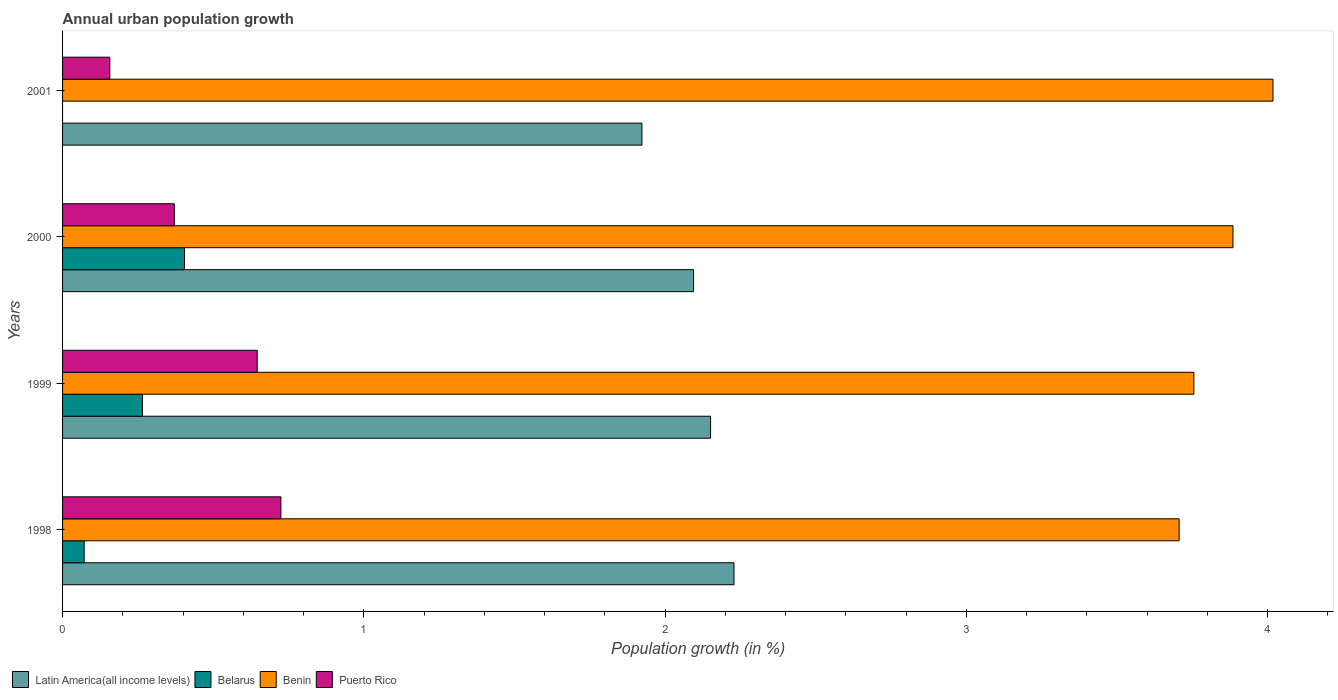How many different coloured bars are there?
Ensure brevity in your answer.  4. How many bars are there on the 4th tick from the bottom?
Offer a very short reply. 3. Across all years, what is the maximum percentage of urban population growth in Puerto Rico?
Provide a short and direct response. 0.72. Across all years, what is the minimum percentage of urban population growth in Puerto Rico?
Your answer should be compact. 0.16. What is the total percentage of urban population growth in Belarus in the graph?
Offer a terse response. 0.74. What is the difference between the percentage of urban population growth in Puerto Rico in 1998 and that in 2000?
Your answer should be compact. 0.35. What is the difference between the percentage of urban population growth in Belarus in 2000 and the percentage of urban population growth in Latin America(all income levels) in 1998?
Give a very brief answer. -1.82. What is the average percentage of urban population growth in Puerto Rico per year?
Provide a succinct answer. 0.47. In the year 2001, what is the difference between the percentage of urban population growth in Puerto Rico and percentage of urban population growth in Benin?
Offer a very short reply. -3.86. What is the ratio of the percentage of urban population growth in Belarus in 1999 to that in 2000?
Give a very brief answer. 0.66. Is the difference between the percentage of urban population growth in Puerto Rico in 1999 and 2000 greater than the difference between the percentage of urban population growth in Benin in 1999 and 2000?
Give a very brief answer. Yes. What is the difference between the highest and the second highest percentage of urban population growth in Puerto Rico?
Give a very brief answer. 0.08. What is the difference between the highest and the lowest percentage of urban population growth in Latin America(all income levels)?
Provide a short and direct response. 0.31. Is the sum of the percentage of urban population growth in Belarus in 1999 and 2000 greater than the maximum percentage of urban population growth in Latin America(all income levels) across all years?
Make the answer very short. No. Is it the case that in every year, the sum of the percentage of urban population growth in Benin and percentage of urban population growth in Puerto Rico is greater than the sum of percentage of urban population growth in Belarus and percentage of urban population growth in Latin America(all income levels)?
Your response must be concise. No. Are all the bars in the graph horizontal?
Offer a terse response. Yes. Are the values on the major ticks of X-axis written in scientific E-notation?
Provide a succinct answer. No. Where does the legend appear in the graph?
Provide a short and direct response. Bottom left. How are the legend labels stacked?
Provide a short and direct response. Horizontal. What is the title of the graph?
Provide a succinct answer. Annual urban population growth. What is the label or title of the X-axis?
Your response must be concise. Population growth (in %). What is the Population growth (in %) of Latin America(all income levels) in 1998?
Your answer should be very brief. 2.23. What is the Population growth (in %) of Belarus in 1998?
Give a very brief answer. 0.07. What is the Population growth (in %) of Benin in 1998?
Your answer should be very brief. 3.71. What is the Population growth (in %) in Puerto Rico in 1998?
Your response must be concise. 0.72. What is the Population growth (in %) of Latin America(all income levels) in 1999?
Ensure brevity in your answer.  2.15. What is the Population growth (in %) of Belarus in 1999?
Provide a short and direct response. 0.27. What is the Population growth (in %) in Benin in 1999?
Keep it short and to the point. 3.76. What is the Population growth (in %) of Puerto Rico in 1999?
Provide a succinct answer. 0.65. What is the Population growth (in %) of Latin America(all income levels) in 2000?
Give a very brief answer. 2.09. What is the Population growth (in %) of Belarus in 2000?
Keep it short and to the point. 0.4. What is the Population growth (in %) in Benin in 2000?
Ensure brevity in your answer.  3.88. What is the Population growth (in %) in Puerto Rico in 2000?
Make the answer very short. 0.37. What is the Population growth (in %) in Latin America(all income levels) in 2001?
Your answer should be compact. 1.92. What is the Population growth (in %) of Benin in 2001?
Your response must be concise. 4.02. What is the Population growth (in %) in Puerto Rico in 2001?
Provide a succinct answer. 0.16. Across all years, what is the maximum Population growth (in %) of Latin America(all income levels)?
Keep it short and to the point. 2.23. Across all years, what is the maximum Population growth (in %) in Belarus?
Your response must be concise. 0.4. Across all years, what is the maximum Population growth (in %) in Benin?
Your answer should be compact. 4.02. Across all years, what is the maximum Population growth (in %) in Puerto Rico?
Your answer should be very brief. 0.72. Across all years, what is the minimum Population growth (in %) in Latin America(all income levels)?
Your answer should be compact. 1.92. Across all years, what is the minimum Population growth (in %) in Belarus?
Offer a very short reply. 0. Across all years, what is the minimum Population growth (in %) in Benin?
Your response must be concise. 3.71. Across all years, what is the minimum Population growth (in %) in Puerto Rico?
Provide a short and direct response. 0.16. What is the total Population growth (in %) of Latin America(all income levels) in the graph?
Make the answer very short. 8.4. What is the total Population growth (in %) of Belarus in the graph?
Provide a succinct answer. 0.74. What is the total Population growth (in %) in Benin in the graph?
Your answer should be compact. 15.36. What is the total Population growth (in %) of Puerto Rico in the graph?
Offer a very short reply. 1.9. What is the difference between the Population growth (in %) in Latin America(all income levels) in 1998 and that in 1999?
Give a very brief answer. 0.08. What is the difference between the Population growth (in %) of Belarus in 1998 and that in 1999?
Keep it short and to the point. -0.19. What is the difference between the Population growth (in %) in Benin in 1998 and that in 1999?
Offer a terse response. -0.05. What is the difference between the Population growth (in %) of Puerto Rico in 1998 and that in 1999?
Give a very brief answer. 0.08. What is the difference between the Population growth (in %) of Latin America(all income levels) in 1998 and that in 2000?
Ensure brevity in your answer.  0.13. What is the difference between the Population growth (in %) in Belarus in 1998 and that in 2000?
Provide a short and direct response. -0.33. What is the difference between the Population growth (in %) of Benin in 1998 and that in 2000?
Give a very brief answer. -0.18. What is the difference between the Population growth (in %) in Puerto Rico in 1998 and that in 2000?
Your answer should be compact. 0.35. What is the difference between the Population growth (in %) of Latin America(all income levels) in 1998 and that in 2001?
Keep it short and to the point. 0.31. What is the difference between the Population growth (in %) of Benin in 1998 and that in 2001?
Your answer should be very brief. -0.31. What is the difference between the Population growth (in %) in Puerto Rico in 1998 and that in 2001?
Ensure brevity in your answer.  0.57. What is the difference between the Population growth (in %) in Latin America(all income levels) in 1999 and that in 2000?
Ensure brevity in your answer.  0.06. What is the difference between the Population growth (in %) in Belarus in 1999 and that in 2000?
Offer a very short reply. -0.14. What is the difference between the Population growth (in %) of Benin in 1999 and that in 2000?
Offer a very short reply. -0.13. What is the difference between the Population growth (in %) in Puerto Rico in 1999 and that in 2000?
Your answer should be very brief. 0.28. What is the difference between the Population growth (in %) in Latin America(all income levels) in 1999 and that in 2001?
Offer a very short reply. 0.23. What is the difference between the Population growth (in %) of Benin in 1999 and that in 2001?
Provide a succinct answer. -0.26. What is the difference between the Population growth (in %) in Puerto Rico in 1999 and that in 2001?
Offer a terse response. 0.49. What is the difference between the Population growth (in %) of Latin America(all income levels) in 2000 and that in 2001?
Your response must be concise. 0.17. What is the difference between the Population growth (in %) in Benin in 2000 and that in 2001?
Your answer should be very brief. -0.13. What is the difference between the Population growth (in %) in Puerto Rico in 2000 and that in 2001?
Your response must be concise. 0.21. What is the difference between the Population growth (in %) in Latin America(all income levels) in 1998 and the Population growth (in %) in Belarus in 1999?
Make the answer very short. 1.96. What is the difference between the Population growth (in %) in Latin America(all income levels) in 1998 and the Population growth (in %) in Benin in 1999?
Offer a very short reply. -1.53. What is the difference between the Population growth (in %) of Latin America(all income levels) in 1998 and the Population growth (in %) of Puerto Rico in 1999?
Offer a terse response. 1.58. What is the difference between the Population growth (in %) in Belarus in 1998 and the Population growth (in %) in Benin in 1999?
Give a very brief answer. -3.68. What is the difference between the Population growth (in %) of Belarus in 1998 and the Population growth (in %) of Puerto Rico in 1999?
Offer a terse response. -0.57. What is the difference between the Population growth (in %) of Benin in 1998 and the Population growth (in %) of Puerto Rico in 1999?
Your answer should be very brief. 3.06. What is the difference between the Population growth (in %) in Latin America(all income levels) in 1998 and the Population growth (in %) in Belarus in 2000?
Your response must be concise. 1.82. What is the difference between the Population growth (in %) in Latin America(all income levels) in 1998 and the Population growth (in %) in Benin in 2000?
Provide a succinct answer. -1.66. What is the difference between the Population growth (in %) in Latin America(all income levels) in 1998 and the Population growth (in %) in Puerto Rico in 2000?
Offer a very short reply. 1.86. What is the difference between the Population growth (in %) in Belarus in 1998 and the Population growth (in %) in Benin in 2000?
Make the answer very short. -3.81. What is the difference between the Population growth (in %) in Belarus in 1998 and the Population growth (in %) in Puerto Rico in 2000?
Your answer should be compact. -0.3. What is the difference between the Population growth (in %) in Benin in 1998 and the Population growth (in %) in Puerto Rico in 2000?
Your answer should be compact. 3.34. What is the difference between the Population growth (in %) in Latin America(all income levels) in 1998 and the Population growth (in %) in Benin in 2001?
Give a very brief answer. -1.79. What is the difference between the Population growth (in %) in Latin America(all income levels) in 1998 and the Population growth (in %) in Puerto Rico in 2001?
Your answer should be compact. 2.07. What is the difference between the Population growth (in %) in Belarus in 1998 and the Population growth (in %) in Benin in 2001?
Provide a short and direct response. -3.95. What is the difference between the Population growth (in %) of Belarus in 1998 and the Population growth (in %) of Puerto Rico in 2001?
Give a very brief answer. -0.09. What is the difference between the Population growth (in %) in Benin in 1998 and the Population growth (in %) in Puerto Rico in 2001?
Your answer should be compact. 3.55. What is the difference between the Population growth (in %) in Latin America(all income levels) in 1999 and the Population growth (in %) in Belarus in 2000?
Offer a terse response. 1.75. What is the difference between the Population growth (in %) of Latin America(all income levels) in 1999 and the Population growth (in %) of Benin in 2000?
Provide a short and direct response. -1.73. What is the difference between the Population growth (in %) of Latin America(all income levels) in 1999 and the Population growth (in %) of Puerto Rico in 2000?
Keep it short and to the point. 1.78. What is the difference between the Population growth (in %) in Belarus in 1999 and the Population growth (in %) in Benin in 2000?
Your answer should be very brief. -3.62. What is the difference between the Population growth (in %) of Belarus in 1999 and the Population growth (in %) of Puerto Rico in 2000?
Provide a succinct answer. -0.11. What is the difference between the Population growth (in %) of Benin in 1999 and the Population growth (in %) of Puerto Rico in 2000?
Ensure brevity in your answer.  3.38. What is the difference between the Population growth (in %) of Latin America(all income levels) in 1999 and the Population growth (in %) of Benin in 2001?
Offer a terse response. -1.87. What is the difference between the Population growth (in %) in Latin America(all income levels) in 1999 and the Population growth (in %) in Puerto Rico in 2001?
Ensure brevity in your answer.  1.99. What is the difference between the Population growth (in %) of Belarus in 1999 and the Population growth (in %) of Benin in 2001?
Your answer should be very brief. -3.75. What is the difference between the Population growth (in %) in Belarus in 1999 and the Population growth (in %) in Puerto Rico in 2001?
Your answer should be very brief. 0.11. What is the difference between the Population growth (in %) in Benin in 1999 and the Population growth (in %) in Puerto Rico in 2001?
Give a very brief answer. 3.6. What is the difference between the Population growth (in %) of Latin America(all income levels) in 2000 and the Population growth (in %) of Benin in 2001?
Make the answer very short. -1.92. What is the difference between the Population growth (in %) of Latin America(all income levels) in 2000 and the Population growth (in %) of Puerto Rico in 2001?
Provide a short and direct response. 1.94. What is the difference between the Population growth (in %) of Belarus in 2000 and the Population growth (in %) of Benin in 2001?
Offer a very short reply. -3.61. What is the difference between the Population growth (in %) of Belarus in 2000 and the Population growth (in %) of Puerto Rico in 2001?
Offer a very short reply. 0.25. What is the difference between the Population growth (in %) of Benin in 2000 and the Population growth (in %) of Puerto Rico in 2001?
Provide a succinct answer. 3.73. What is the average Population growth (in %) in Latin America(all income levels) per year?
Provide a succinct answer. 2.1. What is the average Population growth (in %) in Belarus per year?
Give a very brief answer. 0.19. What is the average Population growth (in %) of Benin per year?
Provide a short and direct response. 3.84. What is the average Population growth (in %) of Puerto Rico per year?
Give a very brief answer. 0.47. In the year 1998, what is the difference between the Population growth (in %) of Latin America(all income levels) and Population growth (in %) of Belarus?
Make the answer very short. 2.16. In the year 1998, what is the difference between the Population growth (in %) in Latin America(all income levels) and Population growth (in %) in Benin?
Make the answer very short. -1.48. In the year 1998, what is the difference between the Population growth (in %) in Latin America(all income levels) and Population growth (in %) in Puerto Rico?
Give a very brief answer. 1.5. In the year 1998, what is the difference between the Population growth (in %) of Belarus and Population growth (in %) of Benin?
Offer a very short reply. -3.63. In the year 1998, what is the difference between the Population growth (in %) in Belarus and Population growth (in %) in Puerto Rico?
Offer a terse response. -0.65. In the year 1998, what is the difference between the Population growth (in %) of Benin and Population growth (in %) of Puerto Rico?
Your answer should be very brief. 2.98. In the year 1999, what is the difference between the Population growth (in %) of Latin America(all income levels) and Population growth (in %) of Belarus?
Give a very brief answer. 1.89. In the year 1999, what is the difference between the Population growth (in %) of Latin America(all income levels) and Population growth (in %) of Benin?
Your response must be concise. -1.6. In the year 1999, what is the difference between the Population growth (in %) of Latin America(all income levels) and Population growth (in %) of Puerto Rico?
Offer a terse response. 1.5. In the year 1999, what is the difference between the Population growth (in %) in Belarus and Population growth (in %) in Benin?
Offer a terse response. -3.49. In the year 1999, what is the difference between the Population growth (in %) of Belarus and Population growth (in %) of Puerto Rico?
Offer a very short reply. -0.38. In the year 1999, what is the difference between the Population growth (in %) of Benin and Population growth (in %) of Puerto Rico?
Offer a terse response. 3.11. In the year 2000, what is the difference between the Population growth (in %) of Latin America(all income levels) and Population growth (in %) of Belarus?
Your answer should be very brief. 1.69. In the year 2000, what is the difference between the Population growth (in %) of Latin America(all income levels) and Population growth (in %) of Benin?
Make the answer very short. -1.79. In the year 2000, what is the difference between the Population growth (in %) of Latin America(all income levels) and Population growth (in %) of Puerto Rico?
Provide a short and direct response. 1.72. In the year 2000, what is the difference between the Population growth (in %) of Belarus and Population growth (in %) of Benin?
Provide a succinct answer. -3.48. In the year 2000, what is the difference between the Population growth (in %) in Belarus and Population growth (in %) in Puerto Rico?
Offer a terse response. 0.03. In the year 2000, what is the difference between the Population growth (in %) of Benin and Population growth (in %) of Puerto Rico?
Keep it short and to the point. 3.51. In the year 2001, what is the difference between the Population growth (in %) of Latin America(all income levels) and Population growth (in %) of Benin?
Your answer should be very brief. -2.09. In the year 2001, what is the difference between the Population growth (in %) of Latin America(all income levels) and Population growth (in %) of Puerto Rico?
Give a very brief answer. 1.77. In the year 2001, what is the difference between the Population growth (in %) in Benin and Population growth (in %) in Puerto Rico?
Offer a very short reply. 3.86. What is the ratio of the Population growth (in %) of Latin America(all income levels) in 1998 to that in 1999?
Provide a succinct answer. 1.04. What is the ratio of the Population growth (in %) in Belarus in 1998 to that in 1999?
Provide a short and direct response. 0.27. What is the ratio of the Population growth (in %) in Benin in 1998 to that in 1999?
Keep it short and to the point. 0.99. What is the ratio of the Population growth (in %) in Puerto Rico in 1998 to that in 1999?
Offer a very short reply. 1.12. What is the ratio of the Population growth (in %) of Latin America(all income levels) in 1998 to that in 2000?
Give a very brief answer. 1.06. What is the ratio of the Population growth (in %) in Belarus in 1998 to that in 2000?
Offer a terse response. 0.18. What is the ratio of the Population growth (in %) in Benin in 1998 to that in 2000?
Your answer should be very brief. 0.95. What is the ratio of the Population growth (in %) of Puerto Rico in 1998 to that in 2000?
Your answer should be compact. 1.95. What is the ratio of the Population growth (in %) in Latin America(all income levels) in 1998 to that in 2001?
Provide a succinct answer. 1.16. What is the ratio of the Population growth (in %) in Benin in 1998 to that in 2001?
Keep it short and to the point. 0.92. What is the ratio of the Population growth (in %) of Puerto Rico in 1998 to that in 2001?
Make the answer very short. 4.62. What is the ratio of the Population growth (in %) in Latin America(all income levels) in 1999 to that in 2000?
Offer a very short reply. 1.03. What is the ratio of the Population growth (in %) of Belarus in 1999 to that in 2000?
Provide a short and direct response. 0.66. What is the ratio of the Population growth (in %) of Benin in 1999 to that in 2000?
Your response must be concise. 0.97. What is the ratio of the Population growth (in %) of Puerto Rico in 1999 to that in 2000?
Your answer should be very brief. 1.74. What is the ratio of the Population growth (in %) of Latin America(all income levels) in 1999 to that in 2001?
Ensure brevity in your answer.  1.12. What is the ratio of the Population growth (in %) in Benin in 1999 to that in 2001?
Provide a succinct answer. 0.93. What is the ratio of the Population growth (in %) of Puerto Rico in 1999 to that in 2001?
Your answer should be very brief. 4.12. What is the ratio of the Population growth (in %) in Latin America(all income levels) in 2000 to that in 2001?
Keep it short and to the point. 1.09. What is the ratio of the Population growth (in %) in Benin in 2000 to that in 2001?
Offer a terse response. 0.97. What is the ratio of the Population growth (in %) in Puerto Rico in 2000 to that in 2001?
Provide a succinct answer. 2.36. What is the difference between the highest and the second highest Population growth (in %) in Latin America(all income levels)?
Your answer should be compact. 0.08. What is the difference between the highest and the second highest Population growth (in %) of Belarus?
Offer a terse response. 0.14. What is the difference between the highest and the second highest Population growth (in %) in Benin?
Your response must be concise. 0.13. What is the difference between the highest and the second highest Population growth (in %) in Puerto Rico?
Make the answer very short. 0.08. What is the difference between the highest and the lowest Population growth (in %) in Latin America(all income levels)?
Provide a succinct answer. 0.31. What is the difference between the highest and the lowest Population growth (in %) of Belarus?
Provide a succinct answer. 0.4. What is the difference between the highest and the lowest Population growth (in %) in Benin?
Your response must be concise. 0.31. What is the difference between the highest and the lowest Population growth (in %) of Puerto Rico?
Ensure brevity in your answer.  0.57. 